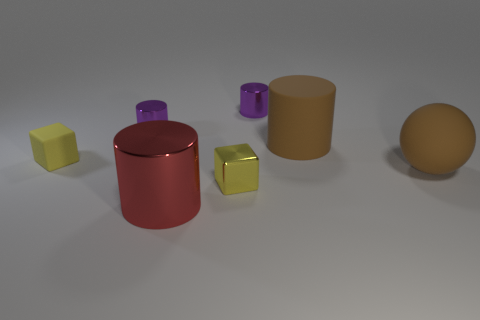There is a brown rubber object on the left side of the ball that is behind the red thing; how many brown cylinders are behind it?
Ensure brevity in your answer.  0. There is another block that is the same color as the small matte block; what is its size?
Offer a very short reply. Small. Are there any brown matte objects behind the small matte cube?
Provide a succinct answer. Yes. What shape is the small rubber object?
Your response must be concise. Cube. What is the shape of the tiny yellow object on the left side of the tiny metal cylinder that is on the left side of the cube in front of the yellow matte object?
Your answer should be compact. Cube. What number of other things are there of the same shape as the yellow matte object?
Make the answer very short. 1. What material is the tiny cube in front of the brown thing that is in front of the small rubber block made of?
Offer a terse response. Metal. Is the red object made of the same material as the yellow block that is right of the tiny yellow rubber thing?
Provide a short and direct response. Yes. There is a large thing that is both behind the yellow metal cube and on the left side of the brown matte ball; what material is it?
Give a very brief answer. Rubber. What color is the small block behind the brown rubber thing in front of the big brown cylinder?
Keep it short and to the point. Yellow. 